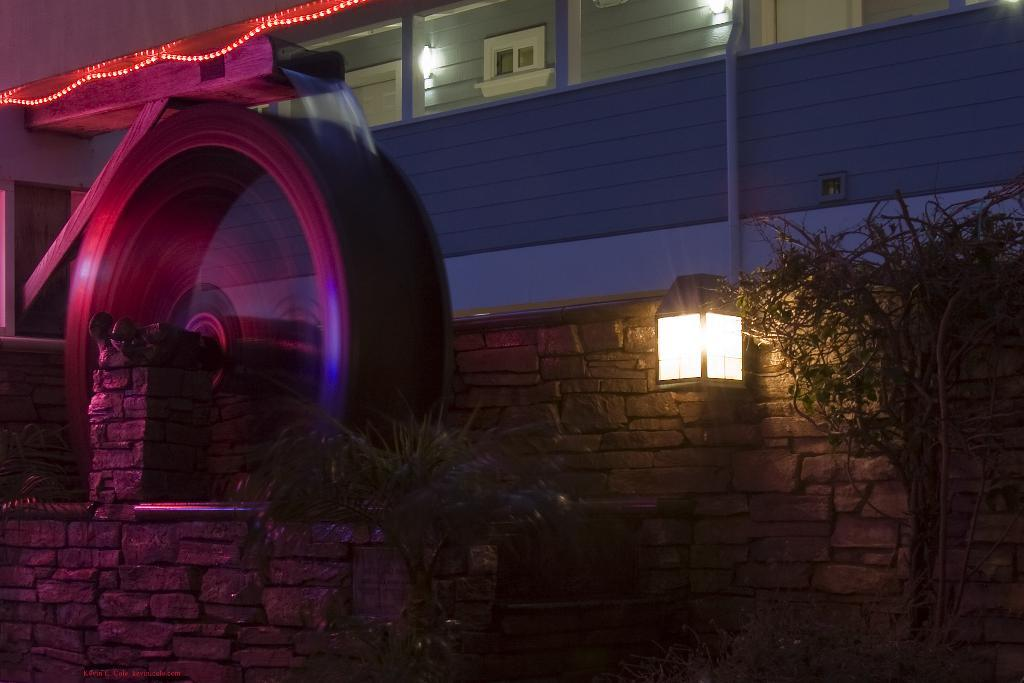What type of structure is present in the image? There is a building in the image. What other architectural feature can be seen in the image? There is a stone wall in the image. What type of vegetation is present in the image? There is a tree and a plant in the image. What can be seen illuminating the scene in the image? There are lights visible in the image. What type of opening or passageway is present in the image? There is an arch in the image. Who is the creator of the scene depicted in the image? The image does not provide information about the creator of the scene. Is there a bridge visible in the image? No, there is no bridge present in the image. 